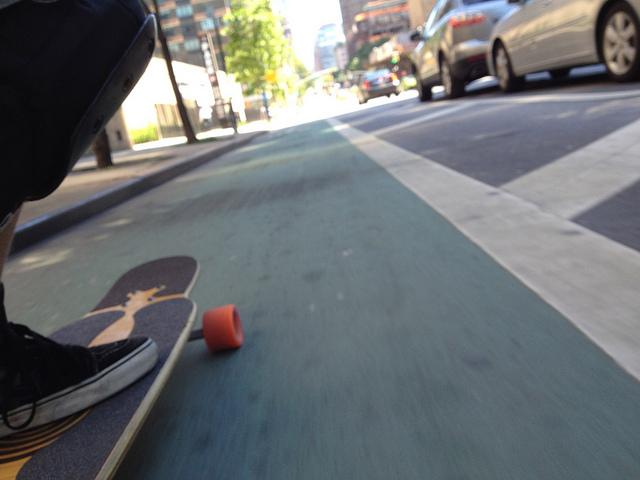What is on top of the skateboard? Please explain your reasoning. sneaker. A shoe is on top the the deck of a skateboard. 